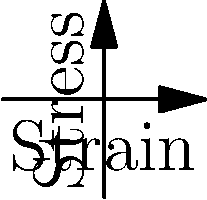Based on the stress-strain curves shown for materials used in traditional and modern athletic equipment, which material would likely provide better energy absorption and reduce the risk of sudden failure during high-impact activities? To answer this question, we need to analyze the stress-strain curves for both materials:

1. Elastic region:
   - Traditional material (blue): Steeper initial slope, indicating higher stiffness.
   - Modern material (red): Less steep initial slope, suggesting more flexibility.

2. Yield point:
   - Traditional material: Occurs at lower strain, transitioning to plastic deformation earlier.
   - Modern material: Occurs at higher strain, allowing more elastic deformation before yielding.

3. Plastic region:
   - Traditional material: Shorter plastic region with a steeper slope.
   - Modern material: Longer plastic region with a more gradual slope.

4. Ultimate strength:
   - Traditional material: Reaches ultimate strength at lower strain.
   - Modern material: Reaches ultimate strength at higher strain.

5. Energy absorption:
   - Energy absorption is related to the area under the stress-strain curve.
   - Modern material has a larger area under its curve, indicating higher energy absorption capacity.

6. Failure characteristics:
   - Traditional material: Sharper transition from elastic to plastic region suggests more sudden failure.
   - Modern material: More gradual transition and longer plastic region indicate more predictable and slower failure.

Given these observations, the modern material would likely provide better energy absorption due to its larger area under the stress-strain curve. It also demonstrates a more gradual transition to failure, reducing the risk of sudden breakage during high-impact activities.
Answer: Modern material 